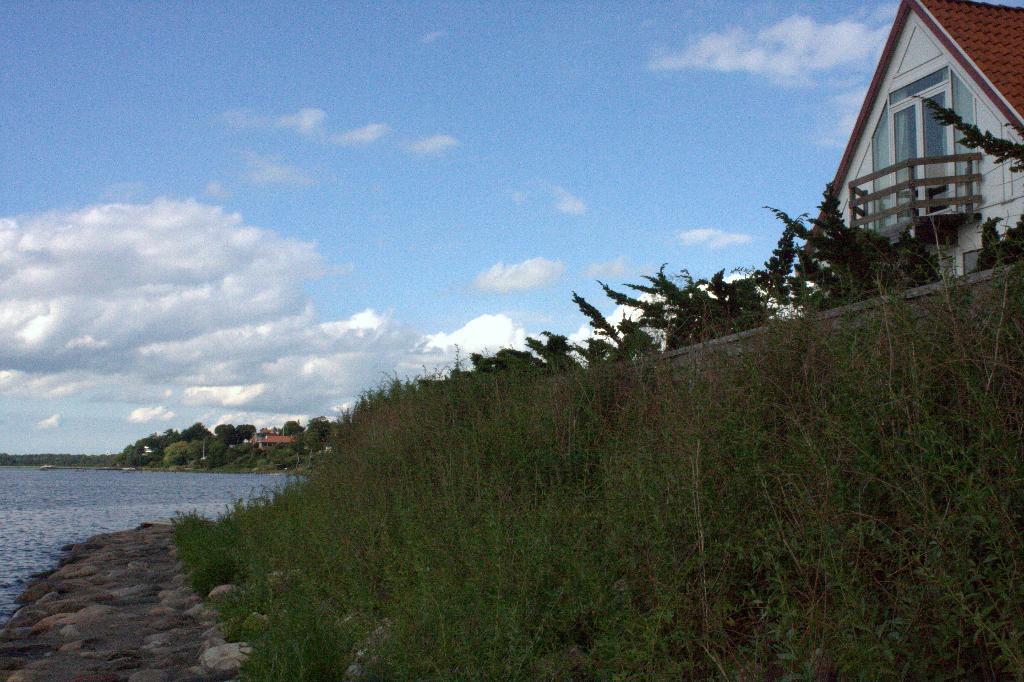Please provide a concise description of this image. In this picture I can see trees, buildings, few plants and I can see water and and a blue cloudy sky. 